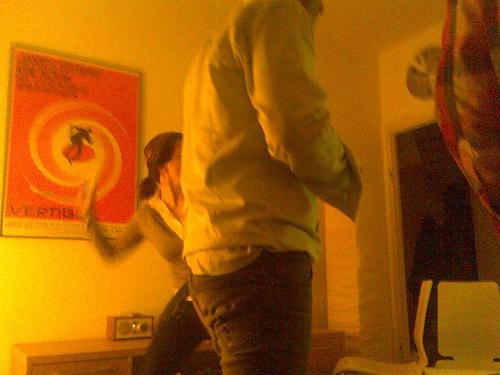What is on the desk?
Short answer required. Radio. What movie poster is on the wall?
Answer briefly. Vertigo. Are the people in a living room?
Give a very brief answer. Yes. 